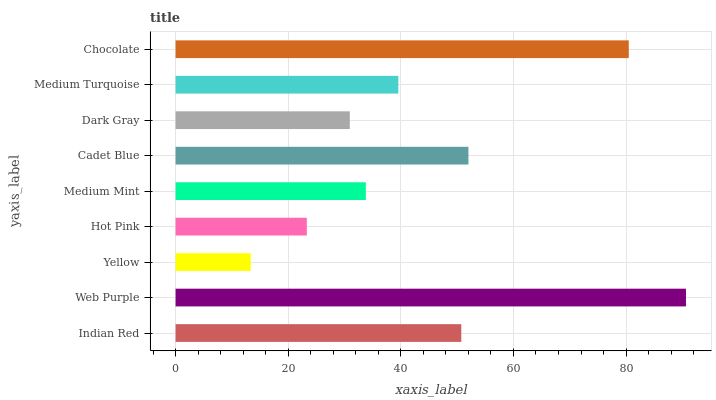Is Yellow the minimum?
Answer yes or no. Yes. Is Web Purple the maximum?
Answer yes or no. Yes. Is Web Purple the minimum?
Answer yes or no. No. Is Yellow the maximum?
Answer yes or no. No. Is Web Purple greater than Yellow?
Answer yes or no. Yes. Is Yellow less than Web Purple?
Answer yes or no. Yes. Is Yellow greater than Web Purple?
Answer yes or no. No. Is Web Purple less than Yellow?
Answer yes or no. No. Is Medium Turquoise the high median?
Answer yes or no. Yes. Is Medium Turquoise the low median?
Answer yes or no. Yes. Is Yellow the high median?
Answer yes or no. No. Is Hot Pink the low median?
Answer yes or no. No. 